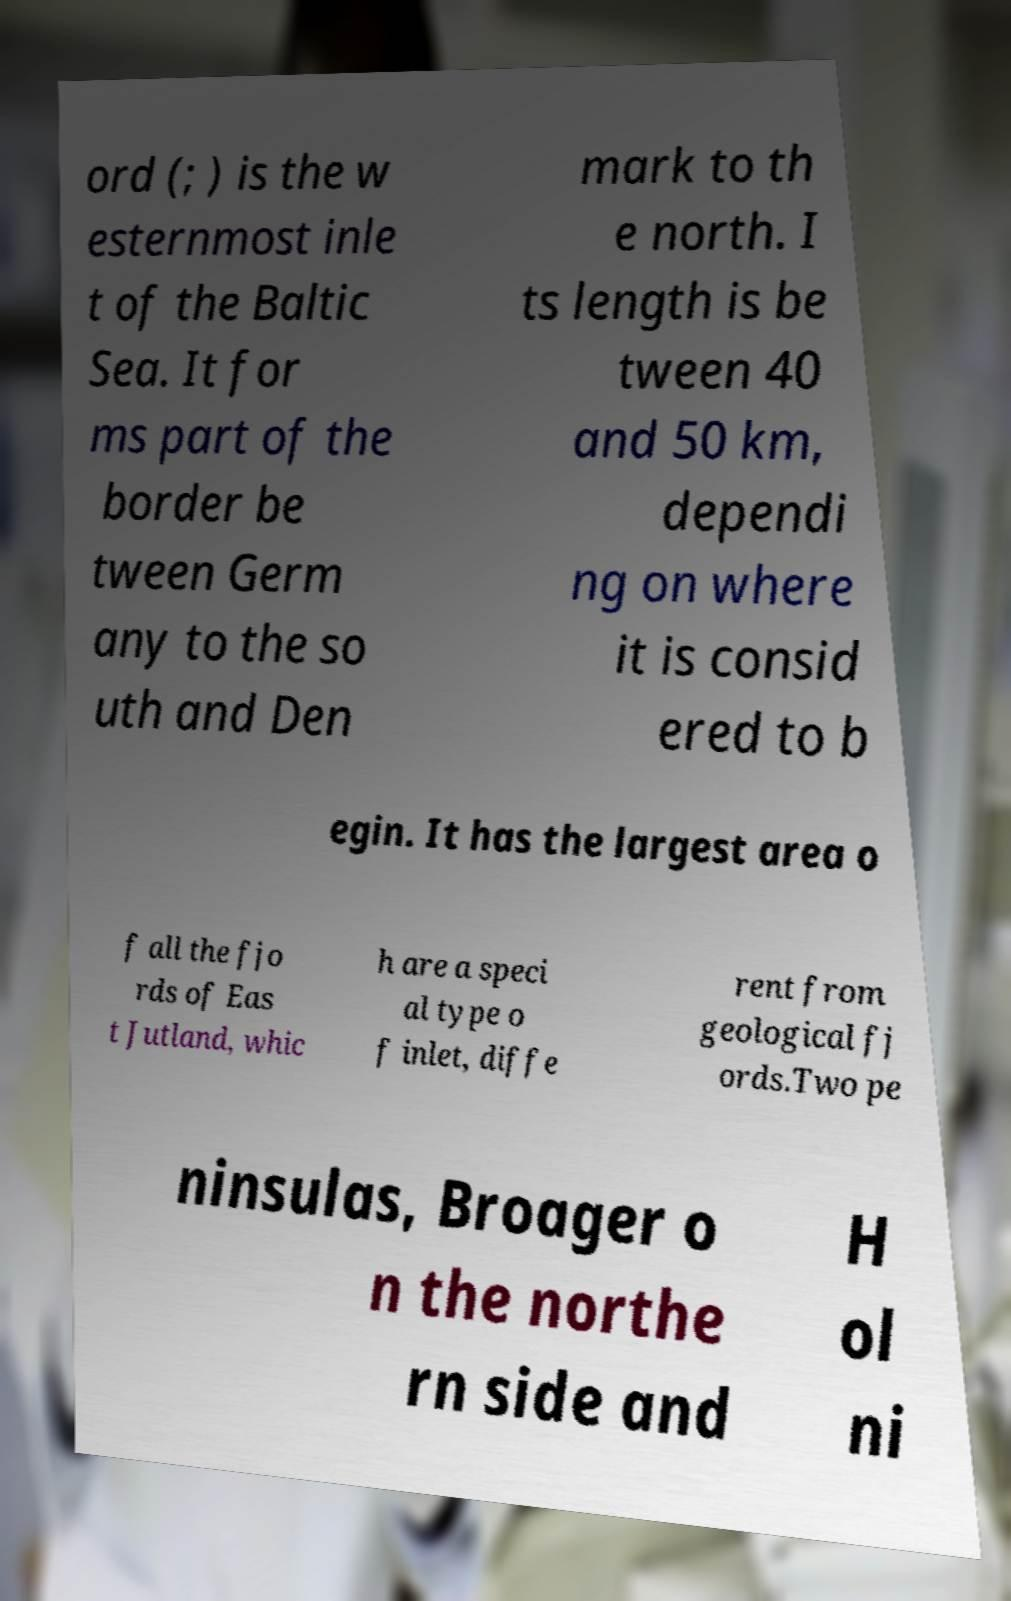Can you read and provide the text displayed in the image?This photo seems to have some interesting text. Can you extract and type it out for me? ord (; ) is the w esternmost inle t of the Baltic Sea. It for ms part of the border be tween Germ any to the so uth and Den mark to th e north. I ts length is be tween 40 and 50 km, dependi ng on where it is consid ered to b egin. It has the largest area o f all the fjo rds of Eas t Jutland, whic h are a speci al type o f inlet, diffe rent from geological fj ords.Two pe ninsulas, Broager o n the northe rn side and H ol ni 